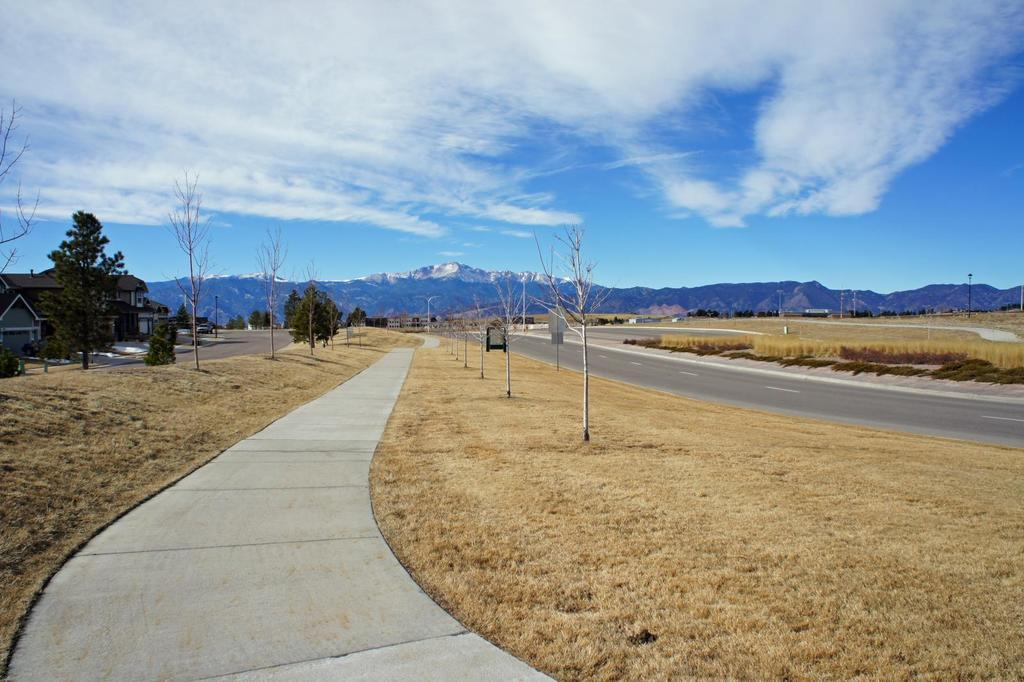What is the main feature of the image? There is an empty road in the image. What type of vegetation is present beside the road? There is yellow grass beside the road. What other natural elements can be seen in the image? There are trees in the image. What man-made structures are visible in the image? There are buildings in the image. What can be seen in the distance in the image? There are mountains in the background of the image. What type of horn can be heard in the image? There is no sound present in the image, so it is not possible to determine if a horn can be heard. 